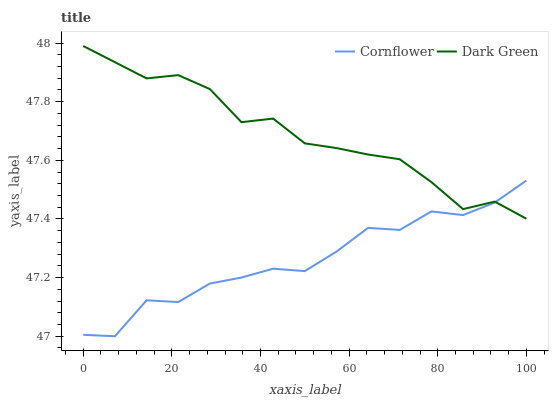Does Cornflower have the minimum area under the curve?
Answer yes or no. Yes. Does Dark Green have the maximum area under the curve?
Answer yes or no. Yes. Does Dark Green have the minimum area under the curve?
Answer yes or no. No. Is Dark Green the smoothest?
Answer yes or no. Yes. Is Cornflower the roughest?
Answer yes or no. Yes. Is Dark Green the roughest?
Answer yes or no. No. Does Dark Green have the lowest value?
Answer yes or no. No. 